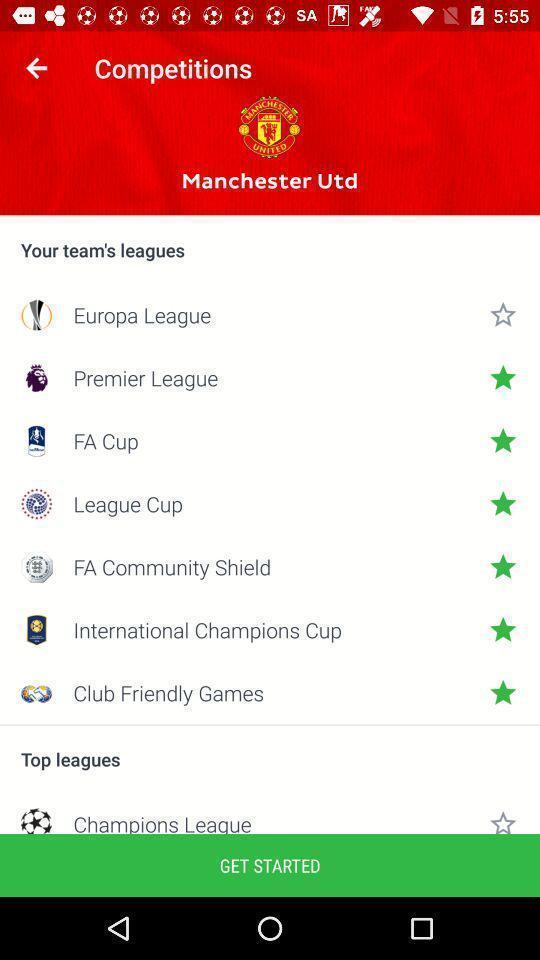Provide a textual representation of this image. Window displaying about soccer game app. 